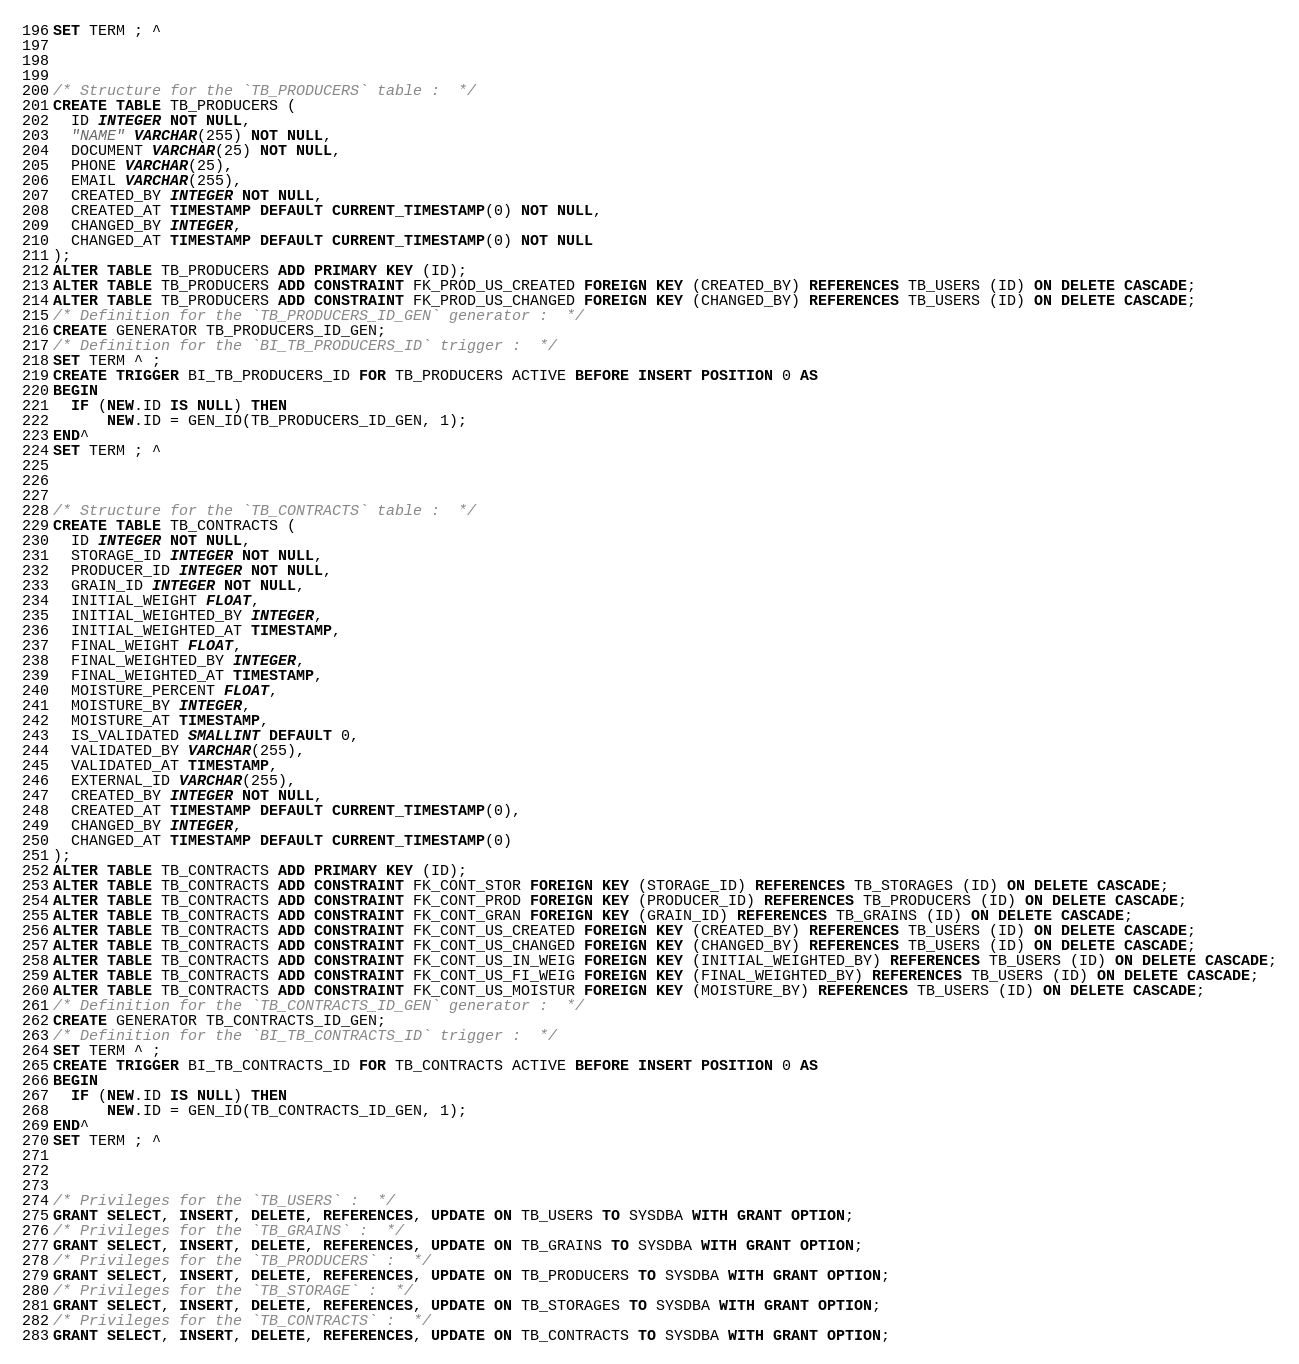<code> <loc_0><loc_0><loc_500><loc_500><_SQL_>SET TERM ; ^



/* Structure for the `TB_PRODUCERS` table :  */
CREATE TABLE TB_PRODUCERS (
  ID INTEGER NOT NULL,
  "NAME" VARCHAR(255) NOT NULL,
  DOCUMENT VARCHAR(25) NOT NULL,
  PHONE VARCHAR(25),
  EMAIL VARCHAR(255),
  CREATED_BY INTEGER NOT NULL,
  CREATED_AT TIMESTAMP DEFAULT CURRENT_TIMESTAMP(0) NOT NULL,
  CHANGED_BY INTEGER,
  CHANGED_AT TIMESTAMP DEFAULT CURRENT_TIMESTAMP(0) NOT NULL
);
ALTER TABLE TB_PRODUCERS ADD PRIMARY KEY (ID);
ALTER TABLE TB_PRODUCERS ADD CONSTRAINT FK_PROD_US_CREATED FOREIGN KEY (CREATED_BY) REFERENCES TB_USERS (ID) ON DELETE CASCADE;
ALTER TABLE TB_PRODUCERS ADD CONSTRAINT FK_PROD_US_CHANGED FOREIGN KEY (CHANGED_BY) REFERENCES TB_USERS (ID) ON DELETE CASCADE;
/* Definition for the `TB_PRODUCERS_ID_GEN` generator :  */
CREATE GENERATOR TB_PRODUCERS_ID_GEN;
/* Definition for the `BI_TB_PRODUCERS_ID` trigger :  */
SET TERM ^ ;
CREATE TRIGGER BI_TB_PRODUCERS_ID FOR TB_PRODUCERS ACTIVE BEFORE INSERT POSITION 0 AS
BEGIN
  IF (NEW.ID IS NULL) THEN
      NEW.ID = GEN_ID(TB_PRODUCERS_ID_GEN, 1);
END^
SET TERM ; ^



/* Structure for the `TB_CONTRACTS` table :  */
CREATE TABLE TB_CONTRACTS (
  ID INTEGER NOT NULL,
  STORAGE_ID INTEGER NOT NULL,
  PRODUCER_ID INTEGER NOT NULL,
  GRAIN_ID INTEGER NOT NULL,
  INITIAL_WEIGHT FLOAT,
  INITIAL_WEIGHTED_BY INTEGER,
  INITIAL_WEIGHTED_AT TIMESTAMP,
  FINAL_WEIGHT FLOAT,
  FINAL_WEIGHTED_BY INTEGER,
  FINAL_WEIGHTED_AT TIMESTAMP,
  MOISTURE_PERCENT FLOAT,
  MOISTURE_BY INTEGER,
  MOISTURE_AT TIMESTAMP,
  IS_VALIDATED SMALLINT DEFAULT 0,
  VALIDATED_BY VARCHAR(255),
  VALIDATED_AT TIMESTAMP,
  EXTERNAL_ID VARCHAR(255),
  CREATED_BY INTEGER NOT NULL,
  CREATED_AT TIMESTAMP DEFAULT CURRENT_TIMESTAMP(0),
  CHANGED_BY INTEGER,
  CHANGED_AT TIMESTAMP DEFAULT CURRENT_TIMESTAMP(0)
);
ALTER TABLE TB_CONTRACTS ADD PRIMARY KEY (ID);
ALTER TABLE TB_CONTRACTS ADD CONSTRAINT FK_CONT_STOR FOREIGN KEY (STORAGE_ID) REFERENCES TB_STORAGES (ID) ON DELETE CASCADE;
ALTER TABLE TB_CONTRACTS ADD CONSTRAINT FK_CONT_PROD FOREIGN KEY (PRODUCER_ID) REFERENCES TB_PRODUCERS (ID) ON DELETE CASCADE;
ALTER TABLE TB_CONTRACTS ADD CONSTRAINT FK_CONT_GRAN FOREIGN KEY (GRAIN_ID) REFERENCES TB_GRAINS (ID) ON DELETE CASCADE;
ALTER TABLE TB_CONTRACTS ADD CONSTRAINT FK_CONT_US_CREATED FOREIGN KEY (CREATED_BY) REFERENCES TB_USERS (ID) ON DELETE CASCADE;
ALTER TABLE TB_CONTRACTS ADD CONSTRAINT FK_CONT_US_CHANGED FOREIGN KEY (CHANGED_BY) REFERENCES TB_USERS (ID) ON DELETE CASCADE;
ALTER TABLE TB_CONTRACTS ADD CONSTRAINT FK_CONT_US_IN_WEIG FOREIGN KEY (INITIAL_WEIGHTED_BY) REFERENCES TB_USERS (ID) ON DELETE CASCADE;
ALTER TABLE TB_CONTRACTS ADD CONSTRAINT FK_CONT_US_FI_WEIG FOREIGN KEY (FINAL_WEIGHTED_BY) REFERENCES TB_USERS (ID) ON DELETE CASCADE;
ALTER TABLE TB_CONTRACTS ADD CONSTRAINT FK_CONT_US_MOISTUR FOREIGN KEY (MOISTURE_BY) REFERENCES TB_USERS (ID) ON DELETE CASCADE;
/* Definition for the `TB_CONTRACTS_ID_GEN` generator :  */
CREATE GENERATOR TB_CONTRACTS_ID_GEN;
/* Definition for the `BI_TB_CONTRACTS_ID` trigger :  */
SET TERM ^ ;
CREATE TRIGGER BI_TB_CONTRACTS_ID FOR TB_CONTRACTS ACTIVE BEFORE INSERT POSITION 0 AS
BEGIN
  IF (NEW.ID IS NULL) THEN
      NEW.ID = GEN_ID(TB_CONTRACTS_ID_GEN, 1);
END^
SET TERM ; ^



/* Privileges for the `TB_USERS` :  */
GRANT SELECT, INSERT, DELETE, REFERENCES, UPDATE ON TB_USERS TO SYSDBA WITH GRANT OPTION;
/* Privileges for the `TB_GRAINS` :  */
GRANT SELECT, INSERT, DELETE, REFERENCES, UPDATE ON TB_GRAINS TO SYSDBA WITH GRANT OPTION;
/* Privileges for the `TB_PRODUCERS` :  */
GRANT SELECT, INSERT, DELETE, REFERENCES, UPDATE ON TB_PRODUCERS TO SYSDBA WITH GRANT OPTION;
/* Privileges for the `TB_STORAGE` :  */
GRANT SELECT, INSERT, DELETE, REFERENCES, UPDATE ON TB_STORAGES TO SYSDBA WITH GRANT OPTION;
/* Privileges for the `TB_CONTRACTS` :  */
GRANT SELECT, INSERT, DELETE, REFERENCES, UPDATE ON TB_CONTRACTS TO SYSDBA WITH GRANT OPTION;</code> 